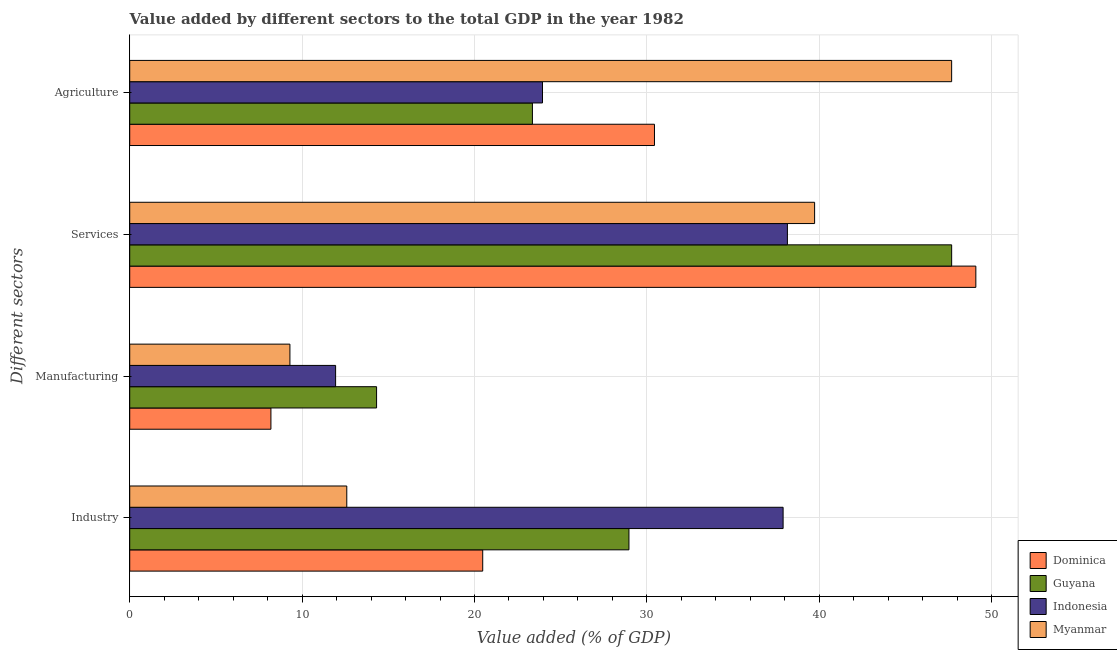How many different coloured bars are there?
Offer a terse response. 4. Are the number of bars per tick equal to the number of legend labels?
Provide a short and direct response. Yes. How many bars are there on the 3rd tick from the top?
Your response must be concise. 4. What is the label of the 2nd group of bars from the top?
Your answer should be very brief. Services. What is the value added by services sector in Dominica?
Provide a succinct answer. 49.08. Across all countries, what is the maximum value added by agricultural sector?
Offer a very short reply. 47.68. Across all countries, what is the minimum value added by industrial sector?
Provide a succinct answer. 12.59. In which country was the value added by manufacturing sector maximum?
Provide a short and direct response. Guyana. In which country was the value added by services sector minimum?
Provide a short and direct response. Indonesia. What is the total value added by manufacturing sector in the graph?
Ensure brevity in your answer.  43.75. What is the difference between the value added by agricultural sector in Myanmar and that in Guyana?
Keep it short and to the point. 24.32. What is the difference between the value added by agricultural sector in Myanmar and the value added by manufacturing sector in Dominica?
Your answer should be compact. 39.49. What is the average value added by agricultural sector per country?
Ensure brevity in your answer.  31.36. What is the difference between the value added by services sector and value added by manufacturing sector in Guyana?
Your answer should be compact. 33.36. What is the ratio of the value added by agricultural sector in Myanmar to that in Indonesia?
Give a very brief answer. 1.99. Is the difference between the value added by industrial sector in Dominica and Myanmar greater than the difference between the value added by manufacturing sector in Dominica and Myanmar?
Offer a very short reply. Yes. What is the difference between the highest and the second highest value added by manufacturing sector?
Your answer should be very brief. 2.38. What is the difference between the highest and the lowest value added by industrial sector?
Your answer should be very brief. 25.31. Is the sum of the value added by agricultural sector in Guyana and Myanmar greater than the maximum value added by services sector across all countries?
Make the answer very short. Yes. Is it the case that in every country, the sum of the value added by agricultural sector and value added by manufacturing sector is greater than the sum of value added by industrial sector and value added by services sector?
Your answer should be very brief. Yes. What does the 2nd bar from the bottom in Services represents?
Your response must be concise. Guyana. Is it the case that in every country, the sum of the value added by industrial sector and value added by manufacturing sector is greater than the value added by services sector?
Provide a succinct answer. No. Are all the bars in the graph horizontal?
Offer a terse response. Yes. Are the values on the major ticks of X-axis written in scientific E-notation?
Provide a short and direct response. No. Where does the legend appear in the graph?
Make the answer very short. Bottom right. How many legend labels are there?
Your answer should be compact. 4. What is the title of the graph?
Provide a succinct answer. Value added by different sectors to the total GDP in the year 1982. Does "Central African Republic" appear as one of the legend labels in the graph?
Give a very brief answer. No. What is the label or title of the X-axis?
Offer a very short reply. Value added (% of GDP). What is the label or title of the Y-axis?
Your answer should be very brief. Different sectors. What is the Value added (% of GDP) of Dominica in Industry?
Offer a very short reply. 20.48. What is the Value added (% of GDP) of Guyana in Industry?
Provide a succinct answer. 28.96. What is the Value added (% of GDP) of Indonesia in Industry?
Make the answer very short. 37.9. What is the Value added (% of GDP) of Myanmar in Industry?
Keep it short and to the point. 12.59. What is the Value added (% of GDP) of Dominica in Manufacturing?
Your answer should be compact. 8.19. What is the Value added (% of GDP) of Guyana in Manufacturing?
Your answer should be very brief. 14.32. What is the Value added (% of GDP) of Indonesia in Manufacturing?
Offer a terse response. 11.94. What is the Value added (% of GDP) of Myanmar in Manufacturing?
Offer a very short reply. 9.29. What is the Value added (% of GDP) of Dominica in Services?
Make the answer very short. 49.08. What is the Value added (% of GDP) in Guyana in Services?
Your response must be concise. 47.68. What is the Value added (% of GDP) of Indonesia in Services?
Make the answer very short. 38.15. What is the Value added (% of GDP) in Myanmar in Services?
Give a very brief answer. 39.73. What is the Value added (% of GDP) in Dominica in Agriculture?
Offer a very short reply. 30.44. What is the Value added (% of GDP) in Guyana in Agriculture?
Keep it short and to the point. 23.36. What is the Value added (% of GDP) of Indonesia in Agriculture?
Offer a very short reply. 23.94. What is the Value added (% of GDP) of Myanmar in Agriculture?
Your answer should be compact. 47.68. Across all Different sectors, what is the maximum Value added (% of GDP) in Dominica?
Keep it short and to the point. 49.08. Across all Different sectors, what is the maximum Value added (% of GDP) of Guyana?
Offer a terse response. 47.68. Across all Different sectors, what is the maximum Value added (% of GDP) in Indonesia?
Offer a very short reply. 38.15. Across all Different sectors, what is the maximum Value added (% of GDP) of Myanmar?
Keep it short and to the point. 47.68. Across all Different sectors, what is the minimum Value added (% of GDP) of Dominica?
Provide a short and direct response. 8.19. Across all Different sectors, what is the minimum Value added (% of GDP) in Guyana?
Your answer should be very brief. 14.32. Across all Different sectors, what is the minimum Value added (% of GDP) in Indonesia?
Your response must be concise. 11.94. Across all Different sectors, what is the minimum Value added (% of GDP) of Myanmar?
Give a very brief answer. 9.29. What is the total Value added (% of GDP) in Dominica in the graph?
Make the answer very short. 108.19. What is the total Value added (% of GDP) in Guyana in the graph?
Your answer should be very brief. 114.32. What is the total Value added (% of GDP) of Indonesia in the graph?
Make the answer very short. 111.94. What is the total Value added (% of GDP) of Myanmar in the graph?
Provide a short and direct response. 109.29. What is the difference between the Value added (% of GDP) of Dominica in Industry and that in Manufacturing?
Your answer should be compact. 12.29. What is the difference between the Value added (% of GDP) of Guyana in Industry and that in Manufacturing?
Provide a succinct answer. 14.64. What is the difference between the Value added (% of GDP) of Indonesia in Industry and that in Manufacturing?
Provide a succinct answer. 25.96. What is the difference between the Value added (% of GDP) in Myanmar in Industry and that in Manufacturing?
Your response must be concise. 3.3. What is the difference between the Value added (% of GDP) of Dominica in Industry and that in Services?
Provide a short and direct response. -28.61. What is the difference between the Value added (% of GDP) of Guyana in Industry and that in Services?
Offer a terse response. -18.72. What is the difference between the Value added (% of GDP) in Indonesia in Industry and that in Services?
Make the answer very short. -0.25. What is the difference between the Value added (% of GDP) of Myanmar in Industry and that in Services?
Offer a terse response. -27.14. What is the difference between the Value added (% of GDP) in Dominica in Industry and that in Agriculture?
Offer a very short reply. -9.96. What is the difference between the Value added (% of GDP) in Guyana in Industry and that in Agriculture?
Your answer should be compact. 5.6. What is the difference between the Value added (% of GDP) of Indonesia in Industry and that in Agriculture?
Offer a terse response. 13.96. What is the difference between the Value added (% of GDP) in Myanmar in Industry and that in Agriculture?
Offer a very short reply. -35.09. What is the difference between the Value added (% of GDP) in Dominica in Manufacturing and that in Services?
Ensure brevity in your answer.  -40.89. What is the difference between the Value added (% of GDP) of Guyana in Manufacturing and that in Services?
Offer a very short reply. -33.36. What is the difference between the Value added (% of GDP) of Indonesia in Manufacturing and that in Services?
Your answer should be compact. -26.21. What is the difference between the Value added (% of GDP) of Myanmar in Manufacturing and that in Services?
Give a very brief answer. -30.44. What is the difference between the Value added (% of GDP) of Dominica in Manufacturing and that in Agriculture?
Offer a very short reply. -22.25. What is the difference between the Value added (% of GDP) in Guyana in Manufacturing and that in Agriculture?
Your answer should be very brief. -9.04. What is the difference between the Value added (% of GDP) of Indonesia in Manufacturing and that in Agriculture?
Offer a terse response. -12. What is the difference between the Value added (% of GDP) of Myanmar in Manufacturing and that in Agriculture?
Your answer should be very brief. -38.39. What is the difference between the Value added (% of GDP) in Dominica in Services and that in Agriculture?
Make the answer very short. 18.64. What is the difference between the Value added (% of GDP) in Guyana in Services and that in Agriculture?
Ensure brevity in your answer.  24.32. What is the difference between the Value added (% of GDP) of Indonesia in Services and that in Agriculture?
Your answer should be compact. 14.21. What is the difference between the Value added (% of GDP) in Myanmar in Services and that in Agriculture?
Provide a succinct answer. -7.95. What is the difference between the Value added (% of GDP) in Dominica in Industry and the Value added (% of GDP) in Guyana in Manufacturing?
Your answer should be compact. 6.16. What is the difference between the Value added (% of GDP) of Dominica in Industry and the Value added (% of GDP) of Indonesia in Manufacturing?
Make the answer very short. 8.53. What is the difference between the Value added (% of GDP) of Dominica in Industry and the Value added (% of GDP) of Myanmar in Manufacturing?
Offer a very short reply. 11.18. What is the difference between the Value added (% of GDP) in Guyana in Industry and the Value added (% of GDP) in Indonesia in Manufacturing?
Provide a succinct answer. 17.02. What is the difference between the Value added (% of GDP) in Guyana in Industry and the Value added (% of GDP) in Myanmar in Manufacturing?
Offer a terse response. 19.67. What is the difference between the Value added (% of GDP) of Indonesia in Industry and the Value added (% of GDP) of Myanmar in Manufacturing?
Your answer should be very brief. 28.61. What is the difference between the Value added (% of GDP) in Dominica in Industry and the Value added (% of GDP) in Guyana in Services?
Provide a short and direct response. -27.2. What is the difference between the Value added (% of GDP) in Dominica in Industry and the Value added (% of GDP) in Indonesia in Services?
Ensure brevity in your answer.  -17.68. What is the difference between the Value added (% of GDP) of Dominica in Industry and the Value added (% of GDP) of Myanmar in Services?
Give a very brief answer. -19.25. What is the difference between the Value added (% of GDP) in Guyana in Industry and the Value added (% of GDP) in Indonesia in Services?
Your answer should be compact. -9.19. What is the difference between the Value added (% of GDP) in Guyana in Industry and the Value added (% of GDP) in Myanmar in Services?
Your answer should be compact. -10.77. What is the difference between the Value added (% of GDP) in Indonesia in Industry and the Value added (% of GDP) in Myanmar in Services?
Provide a short and direct response. -1.83. What is the difference between the Value added (% of GDP) in Dominica in Industry and the Value added (% of GDP) in Guyana in Agriculture?
Provide a succinct answer. -2.88. What is the difference between the Value added (% of GDP) in Dominica in Industry and the Value added (% of GDP) in Indonesia in Agriculture?
Offer a terse response. -3.47. What is the difference between the Value added (% of GDP) in Dominica in Industry and the Value added (% of GDP) in Myanmar in Agriculture?
Make the answer very short. -27.2. What is the difference between the Value added (% of GDP) of Guyana in Industry and the Value added (% of GDP) of Indonesia in Agriculture?
Offer a terse response. 5.02. What is the difference between the Value added (% of GDP) of Guyana in Industry and the Value added (% of GDP) of Myanmar in Agriculture?
Your answer should be compact. -18.72. What is the difference between the Value added (% of GDP) of Indonesia in Industry and the Value added (% of GDP) of Myanmar in Agriculture?
Offer a terse response. -9.78. What is the difference between the Value added (% of GDP) in Dominica in Manufacturing and the Value added (% of GDP) in Guyana in Services?
Your response must be concise. -39.49. What is the difference between the Value added (% of GDP) in Dominica in Manufacturing and the Value added (% of GDP) in Indonesia in Services?
Make the answer very short. -29.96. What is the difference between the Value added (% of GDP) in Dominica in Manufacturing and the Value added (% of GDP) in Myanmar in Services?
Offer a terse response. -31.54. What is the difference between the Value added (% of GDP) of Guyana in Manufacturing and the Value added (% of GDP) of Indonesia in Services?
Your answer should be very brief. -23.83. What is the difference between the Value added (% of GDP) of Guyana in Manufacturing and the Value added (% of GDP) of Myanmar in Services?
Ensure brevity in your answer.  -25.41. What is the difference between the Value added (% of GDP) in Indonesia in Manufacturing and the Value added (% of GDP) in Myanmar in Services?
Offer a terse response. -27.79. What is the difference between the Value added (% of GDP) of Dominica in Manufacturing and the Value added (% of GDP) of Guyana in Agriculture?
Ensure brevity in your answer.  -15.17. What is the difference between the Value added (% of GDP) of Dominica in Manufacturing and the Value added (% of GDP) of Indonesia in Agriculture?
Make the answer very short. -15.75. What is the difference between the Value added (% of GDP) in Dominica in Manufacturing and the Value added (% of GDP) in Myanmar in Agriculture?
Give a very brief answer. -39.49. What is the difference between the Value added (% of GDP) of Guyana in Manufacturing and the Value added (% of GDP) of Indonesia in Agriculture?
Your answer should be very brief. -9.62. What is the difference between the Value added (% of GDP) in Guyana in Manufacturing and the Value added (% of GDP) in Myanmar in Agriculture?
Keep it short and to the point. -33.36. What is the difference between the Value added (% of GDP) in Indonesia in Manufacturing and the Value added (% of GDP) in Myanmar in Agriculture?
Ensure brevity in your answer.  -35.74. What is the difference between the Value added (% of GDP) of Dominica in Services and the Value added (% of GDP) of Guyana in Agriculture?
Offer a very short reply. 25.72. What is the difference between the Value added (% of GDP) in Dominica in Services and the Value added (% of GDP) in Indonesia in Agriculture?
Your response must be concise. 25.14. What is the difference between the Value added (% of GDP) of Dominica in Services and the Value added (% of GDP) of Myanmar in Agriculture?
Provide a succinct answer. 1.4. What is the difference between the Value added (% of GDP) in Guyana in Services and the Value added (% of GDP) in Indonesia in Agriculture?
Offer a terse response. 23.74. What is the difference between the Value added (% of GDP) of Indonesia in Services and the Value added (% of GDP) of Myanmar in Agriculture?
Offer a terse response. -9.53. What is the average Value added (% of GDP) in Dominica per Different sectors?
Offer a terse response. 27.05. What is the average Value added (% of GDP) in Guyana per Different sectors?
Give a very brief answer. 28.58. What is the average Value added (% of GDP) in Indonesia per Different sectors?
Your answer should be compact. 27.99. What is the average Value added (% of GDP) of Myanmar per Different sectors?
Offer a very short reply. 27.32. What is the difference between the Value added (% of GDP) of Dominica and Value added (% of GDP) of Guyana in Industry?
Keep it short and to the point. -8.48. What is the difference between the Value added (% of GDP) in Dominica and Value added (% of GDP) in Indonesia in Industry?
Offer a terse response. -17.43. What is the difference between the Value added (% of GDP) of Dominica and Value added (% of GDP) of Myanmar in Industry?
Your answer should be compact. 7.89. What is the difference between the Value added (% of GDP) of Guyana and Value added (% of GDP) of Indonesia in Industry?
Provide a short and direct response. -8.94. What is the difference between the Value added (% of GDP) in Guyana and Value added (% of GDP) in Myanmar in Industry?
Your response must be concise. 16.37. What is the difference between the Value added (% of GDP) of Indonesia and Value added (% of GDP) of Myanmar in Industry?
Ensure brevity in your answer.  25.31. What is the difference between the Value added (% of GDP) in Dominica and Value added (% of GDP) in Guyana in Manufacturing?
Your response must be concise. -6.13. What is the difference between the Value added (% of GDP) of Dominica and Value added (% of GDP) of Indonesia in Manufacturing?
Ensure brevity in your answer.  -3.75. What is the difference between the Value added (% of GDP) in Dominica and Value added (% of GDP) in Myanmar in Manufacturing?
Make the answer very short. -1.1. What is the difference between the Value added (% of GDP) in Guyana and Value added (% of GDP) in Indonesia in Manufacturing?
Offer a terse response. 2.38. What is the difference between the Value added (% of GDP) in Guyana and Value added (% of GDP) in Myanmar in Manufacturing?
Ensure brevity in your answer.  5.03. What is the difference between the Value added (% of GDP) of Indonesia and Value added (% of GDP) of Myanmar in Manufacturing?
Provide a short and direct response. 2.65. What is the difference between the Value added (% of GDP) in Dominica and Value added (% of GDP) in Guyana in Services?
Provide a succinct answer. 1.4. What is the difference between the Value added (% of GDP) of Dominica and Value added (% of GDP) of Indonesia in Services?
Your response must be concise. 10.93. What is the difference between the Value added (% of GDP) of Dominica and Value added (% of GDP) of Myanmar in Services?
Your answer should be very brief. 9.35. What is the difference between the Value added (% of GDP) in Guyana and Value added (% of GDP) in Indonesia in Services?
Offer a terse response. 9.53. What is the difference between the Value added (% of GDP) of Guyana and Value added (% of GDP) of Myanmar in Services?
Provide a succinct answer. 7.95. What is the difference between the Value added (% of GDP) in Indonesia and Value added (% of GDP) in Myanmar in Services?
Ensure brevity in your answer.  -1.58. What is the difference between the Value added (% of GDP) in Dominica and Value added (% of GDP) in Guyana in Agriculture?
Offer a terse response. 7.08. What is the difference between the Value added (% of GDP) in Dominica and Value added (% of GDP) in Indonesia in Agriculture?
Offer a terse response. 6.5. What is the difference between the Value added (% of GDP) of Dominica and Value added (% of GDP) of Myanmar in Agriculture?
Offer a terse response. -17.24. What is the difference between the Value added (% of GDP) of Guyana and Value added (% of GDP) of Indonesia in Agriculture?
Keep it short and to the point. -0.58. What is the difference between the Value added (% of GDP) of Guyana and Value added (% of GDP) of Myanmar in Agriculture?
Keep it short and to the point. -24.32. What is the difference between the Value added (% of GDP) in Indonesia and Value added (% of GDP) in Myanmar in Agriculture?
Offer a very short reply. -23.73. What is the ratio of the Value added (% of GDP) of Guyana in Industry to that in Manufacturing?
Offer a terse response. 2.02. What is the ratio of the Value added (% of GDP) in Indonesia in Industry to that in Manufacturing?
Your response must be concise. 3.17. What is the ratio of the Value added (% of GDP) of Myanmar in Industry to that in Manufacturing?
Make the answer very short. 1.35. What is the ratio of the Value added (% of GDP) in Dominica in Industry to that in Services?
Provide a succinct answer. 0.42. What is the ratio of the Value added (% of GDP) of Guyana in Industry to that in Services?
Offer a very short reply. 0.61. What is the ratio of the Value added (% of GDP) of Indonesia in Industry to that in Services?
Provide a short and direct response. 0.99. What is the ratio of the Value added (% of GDP) of Myanmar in Industry to that in Services?
Provide a succinct answer. 0.32. What is the ratio of the Value added (% of GDP) in Dominica in Industry to that in Agriculture?
Offer a very short reply. 0.67. What is the ratio of the Value added (% of GDP) of Guyana in Industry to that in Agriculture?
Offer a very short reply. 1.24. What is the ratio of the Value added (% of GDP) in Indonesia in Industry to that in Agriculture?
Give a very brief answer. 1.58. What is the ratio of the Value added (% of GDP) of Myanmar in Industry to that in Agriculture?
Provide a succinct answer. 0.26. What is the ratio of the Value added (% of GDP) in Dominica in Manufacturing to that in Services?
Make the answer very short. 0.17. What is the ratio of the Value added (% of GDP) of Guyana in Manufacturing to that in Services?
Keep it short and to the point. 0.3. What is the ratio of the Value added (% of GDP) of Indonesia in Manufacturing to that in Services?
Provide a succinct answer. 0.31. What is the ratio of the Value added (% of GDP) of Myanmar in Manufacturing to that in Services?
Provide a succinct answer. 0.23. What is the ratio of the Value added (% of GDP) in Dominica in Manufacturing to that in Agriculture?
Keep it short and to the point. 0.27. What is the ratio of the Value added (% of GDP) in Guyana in Manufacturing to that in Agriculture?
Provide a succinct answer. 0.61. What is the ratio of the Value added (% of GDP) in Indonesia in Manufacturing to that in Agriculture?
Provide a succinct answer. 0.5. What is the ratio of the Value added (% of GDP) in Myanmar in Manufacturing to that in Agriculture?
Offer a very short reply. 0.19. What is the ratio of the Value added (% of GDP) of Dominica in Services to that in Agriculture?
Your response must be concise. 1.61. What is the ratio of the Value added (% of GDP) of Guyana in Services to that in Agriculture?
Make the answer very short. 2.04. What is the ratio of the Value added (% of GDP) in Indonesia in Services to that in Agriculture?
Make the answer very short. 1.59. What is the ratio of the Value added (% of GDP) in Myanmar in Services to that in Agriculture?
Your response must be concise. 0.83. What is the difference between the highest and the second highest Value added (% of GDP) of Dominica?
Ensure brevity in your answer.  18.64. What is the difference between the highest and the second highest Value added (% of GDP) of Guyana?
Your answer should be compact. 18.72. What is the difference between the highest and the second highest Value added (% of GDP) in Indonesia?
Ensure brevity in your answer.  0.25. What is the difference between the highest and the second highest Value added (% of GDP) of Myanmar?
Offer a very short reply. 7.95. What is the difference between the highest and the lowest Value added (% of GDP) of Dominica?
Offer a terse response. 40.89. What is the difference between the highest and the lowest Value added (% of GDP) of Guyana?
Your answer should be very brief. 33.36. What is the difference between the highest and the lowest Value added (% of GDP) of Indonesia?
Offer a very short reply. 26.21. What is the difference between the highest and the lowest Value added (% of GDP) of Myanmar?
Your answer should be very brief. 38.39. 